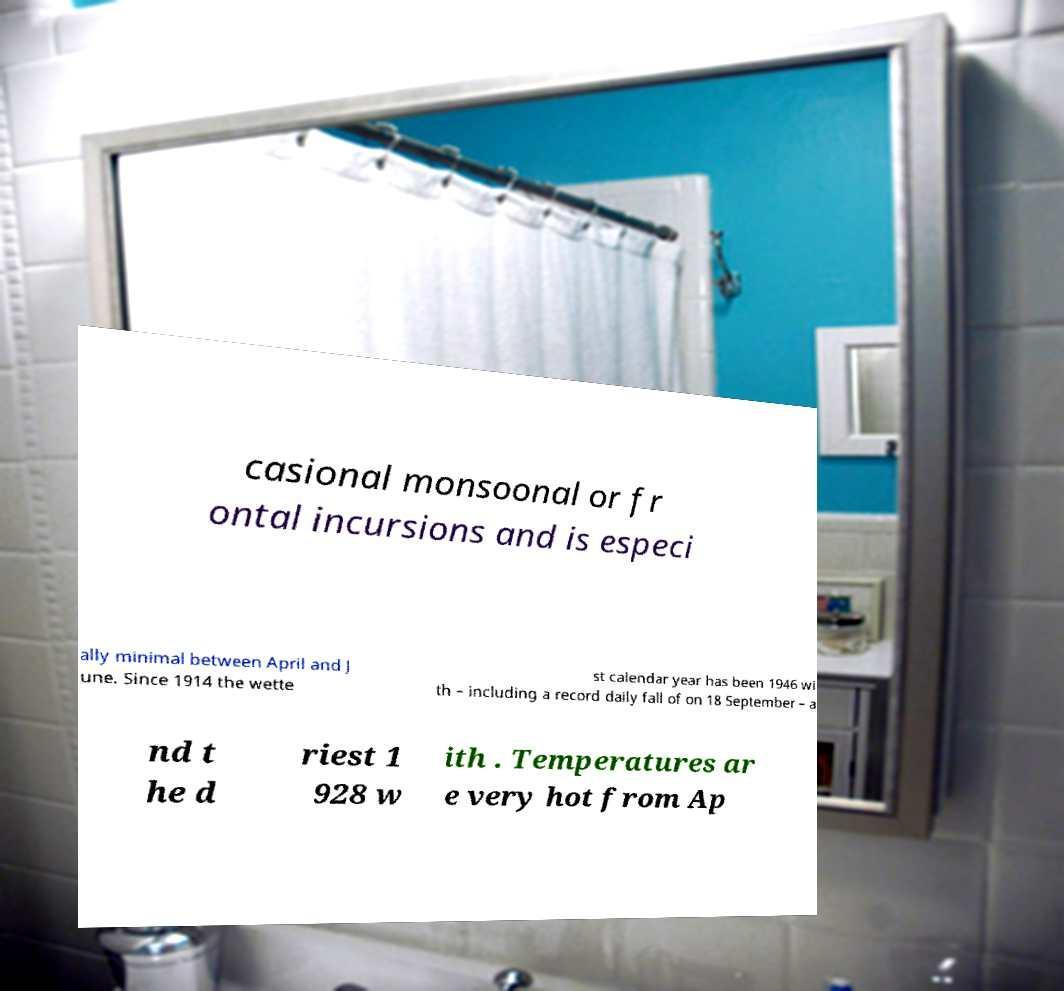Can you accurately transcribe the text from the provided image for me? casional monsoonal or fr ontal incursions and is especi ally minimal between April and J une. Since 1914 the wette st calendar year has been 1946 wi th – including a record daily fall of on 18 September – a nd t he d riest 1 928 w ith . Temperatures ar e very hot from Ap 